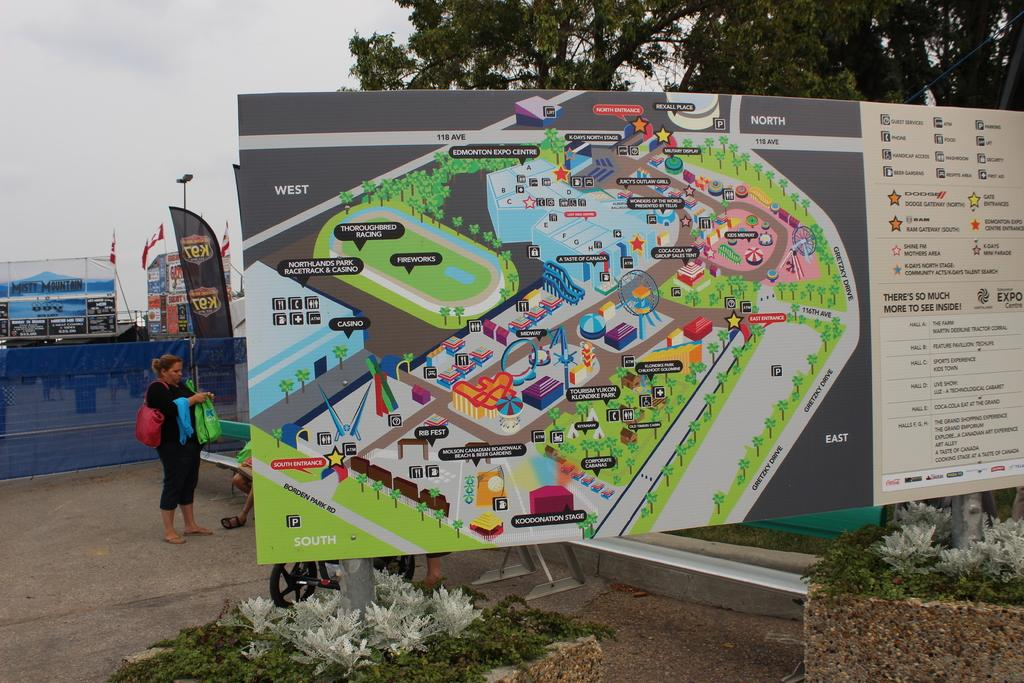What is the main object on the board in the image? There is a map on a board in the image. What can be seen around the rods under the map? There are small plants around the rods under the map. Can you describe the background of the image? In the background of the image, there is a woman, a vehicle, banners, and trees. What type of flowers are growing on the sidewalk in the image? There is no sidewalk or flowers present in the image. 